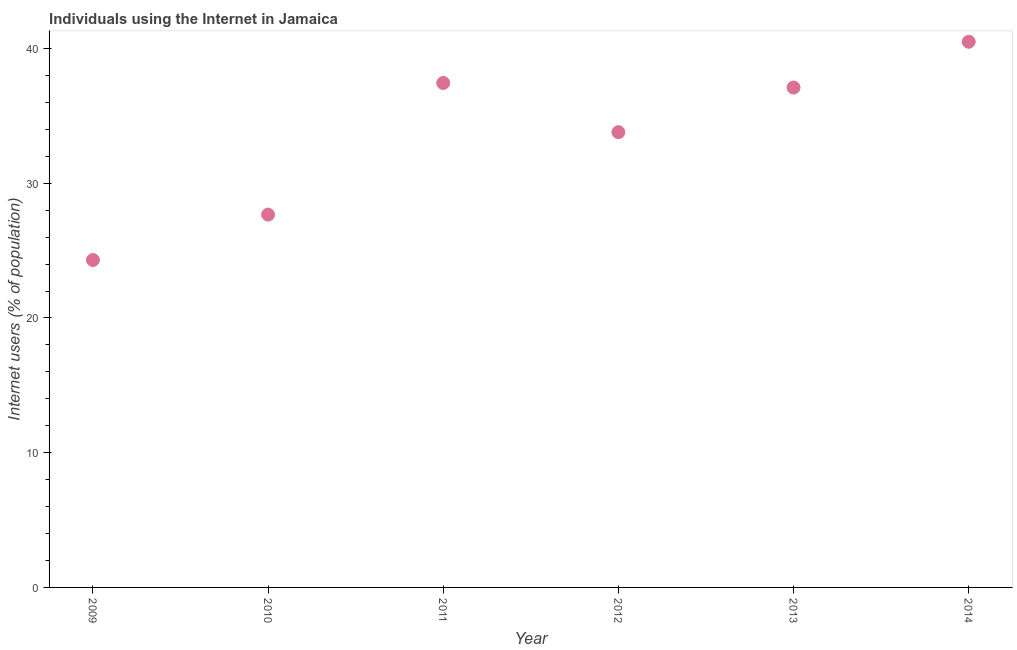What is the number of internet users in 2009?
Your answer should be very brief. 24.3. Across all years, what is the maximum number of internet users?
Your answer should be very brief. 40.5. Across all years, what is the minimum number of internet users?
Your response must be concise. 24.3. What is the sum of the number of internet users?
Offer a very short reply. 200.8. What is the difference between the number of internet users in 2013 and 2014?
Give a very brief answer. -3.4. What is the average number of internet users per year?
Your response must be concise. 33.47. What is the median number of internet users?
Make the answer very short. 35.45. In how many years, is the number of internet users greater than 6 %?
Offer a terse response. 6. Do a majority of the years between 2012 and 2014 (inclusive) have number of internet users greater than 8 %?
Your answer should be compact. Yes. What is the ratio of the number of internet users in 2010 to that in 2011?
Your answer should be very brief. 0.74. Is the number of internet users in 2010 less than that in 2012?
Give a very brief answer. Yes. What is the difference between the highest and the second highest number of internet users?
Give a very brief answer. 3.06. Does the number of internet users monotonically increase over the years?
Make the answer very short. No. Are the values on the major ticks of Y-axis written in scientific E-notation?
Ensure brevity in your answer.  No. Does the graph contain any zero values?
Your answer should be very brief. No. Does the graph contain grids?
Give a very brief answer. No. What is the title of the graph?
Offer a very short reply. Individuals using the Internet in Jamaica. What is the label or title of the X-axis?
Keep it short and to the point. Year. What is the label or title of the Y-axis?
Keep it short and to the point. Internet users (% of population). What is the Internet users (% of population) in 2009?
Give a very brief answer. 24.3. What is the Internet users (% of population) in 2010?
Offer a very short reply. 27.67. What is the Internet users (% of population) in 2011?
Provide a short and direct response. 37.44. What is the Internet users (% of population) in 2012?
Give a very brief answer. 33.79. What is the Internet users (% of population) in 2013?
Keep it short and to the point. 37.1. What is the Internet users (% of population) in 2014?
Your answer should be very brief. 40.5. What is the difference between the Internet users (% of population) in 2009 and 2010?
Provide a short and direct response. -3.37. What is the difference between the Internet users (% of population) in 2009 and 2011?
Provide a short and direct response. -13.14. What is the difference between the Internet users (% of population) in 2009 and 2012?
Keep it short and to the point. -9.49. What is the difference between the Internet users (% of population) in 2009 and 2014?
Make the answer very short. -16.2. What is the difference between the Internet users (% of population) in 2010 and 2011?
Make the answer very short. -9.77. What is the difference between the Internet users (% of population) in 2010 and 2012?
Your answer should be compact. -6.12. What is the difference between the Internet users (% of population) in 2010 and 2013?
Provide a succinct answer. -9.43. What is the difference between the Internet users (% of population) in 2010 and 2014?
Ensure brevity in your answer.  -12.83. What is the difference between the Internet users (% of population) in 2011 and 2012?
Offer a very short reply. 3.65. What is the difference between the Internet users (% of population) in 2011 and 2013?
Make the answer very short. 0.34. What is the difference between the Internet users (% of population) in 2011 and 2014?
Provide a short and direct response. -3.06. What is the difference between the Internet users (% of population) in 2012 and 2013?
Offer a terse response. -3.31. What is the difference between the Internet users (% of population) in 2012 and 2014?
Keep it short and to the point. -6.71. What is the ratio of the Internet users (% of population) in 2009 to that in 2010?
Ensure brevity in your answer.  0.88. What is the ratio of the Internet users (% of population) in 2009 to that in 2011?
Your response must be concise. 0.65. What is the ratio of the Internet users (% of population) in 2009 to that in 2012?
Offer a terse response. 0.72. What is the ratio of the Internet users (% of population) in 2009 to that in 2013?
Make the answer very short. 0.66. What is the ratio of the Internet users (% of population) in 2009 to that in 2014?
Provide a succinct answer. 0.6. What is the ratio of the Internet users (% of population) in 2010 to that in 2011?
Offer a terse response. 0.74. What is the ratio of the Internet users (% of population) in 2010 to that in 2012?
Ensure brevity in your answer.  0.82. What is the ratio of the Internet users (% of population) in 2010 to that in 2013?
Provide a short and direct response. 0.75. What is the ratio of the Internet users (% of population) in 2010 to that in 2014?
Make the answer very short. 0.68. What is the ratio of the Internet users (% of population) in 2011 to that in 2012?
Your response must be concise. 1.11. What is the ratio of the Internet users (% of population) in 2011 to that in 2014?
Ensure brevity in your answer.  0.92. What is the ratio of the Internet users (% of population) in 2012 to that in 2013?
Your answer should be very brief. 0.91. What is the ratio of the Internet users (% of population) in 2012 to that in 2014?
Offer a terse response. 0.83. What is the ratio of the Internet users (% of population) in 2013 to that in 2014?
Your response must be concise. 0.92. 